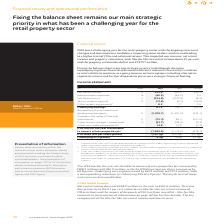According to Intu Properties's financial document, What is the net rental income in 2019? According to the financial document, 401.6 (in millions). The relevant text states: "£m Notes 2019 2018 Change Net rental income A 401.6 450.5 (48.9) Administration expenses B (40.5) (44.0) 3.5 Net finance costs C (224.6) (220.4) (4.2)..." Also, What is the administration expense in 2019? According to the financial document, 40.5 (in millions). The relevant text states: "e A 401.6 450.5 (48.9) Administration expenses B (40.5) (44.0) 3.5 Net finance costs C (224.6) (220.4) (4.2) Tax on underlying profit D (17.6) (0.7) (16.9..." Also, What is the net finance cost in 2019? According to the financial document, 224.6 (in millions). The relevant text states: "expenses B (40.5) (44.0) 3.5 Net finance costs C (224.6) (220.4) (4.2) Tax on underlying profit D (17.6) (0.7) (16.9) Other underlying amounts 2 8.3 7.7 0...." Also, can you calculate: What is the percentage change in the net rental income from 2018 to 2019? Based on the calculation: 48.9/450.5, the result is 10.85 (percentage). This is based on the information: "Notes 2019 2018 Change Net rental income A 401.6 450.5 (48.9) Administration expenses B (40.5) (44.0) 3.5 Net finance costs C (224.6) (220.4) (4.2) Tax on 2019 2018 Change Net rental income A 401.6 45..." The key data points involved are: 450.5, 48.9. Also, can you calculate: What is the percentage change in the administration expenses from 2018 to 2019? Based on the calculation: 3.5/44.0, the result is 7.95 (percentage). This is based on the information: ".5 (48.9) Administration expenses B (40.5) (44.0) 3.5 Net finance costs C (224.6) (220.4) (4.2) Tax on underlying profit D (17.6) (0.7) (16.9) Other unde .6 450.5 (48.9) Administration expenses B (40...." The key data points involved are: 3.5, 44.0. Also, can you calculate: What is the percentage change in the net finance costs from 2018 to 2019? Based on the calculation: (4.2)/220.4, the result is -1.91 (percentage). This is based on the information: ") (44.0) 3.5 Net finance costs C (224.6) (220.4) (4.2) Tax on underlying profit D (17.6) (0.7) (16.9) Other underlying amounts 2 8.3 7.7 0.6 Underlying e B (40.5) (44.0) 3.5 Net finance costs C (224.6..." The key data points involved are: 220.4, 4.2. 